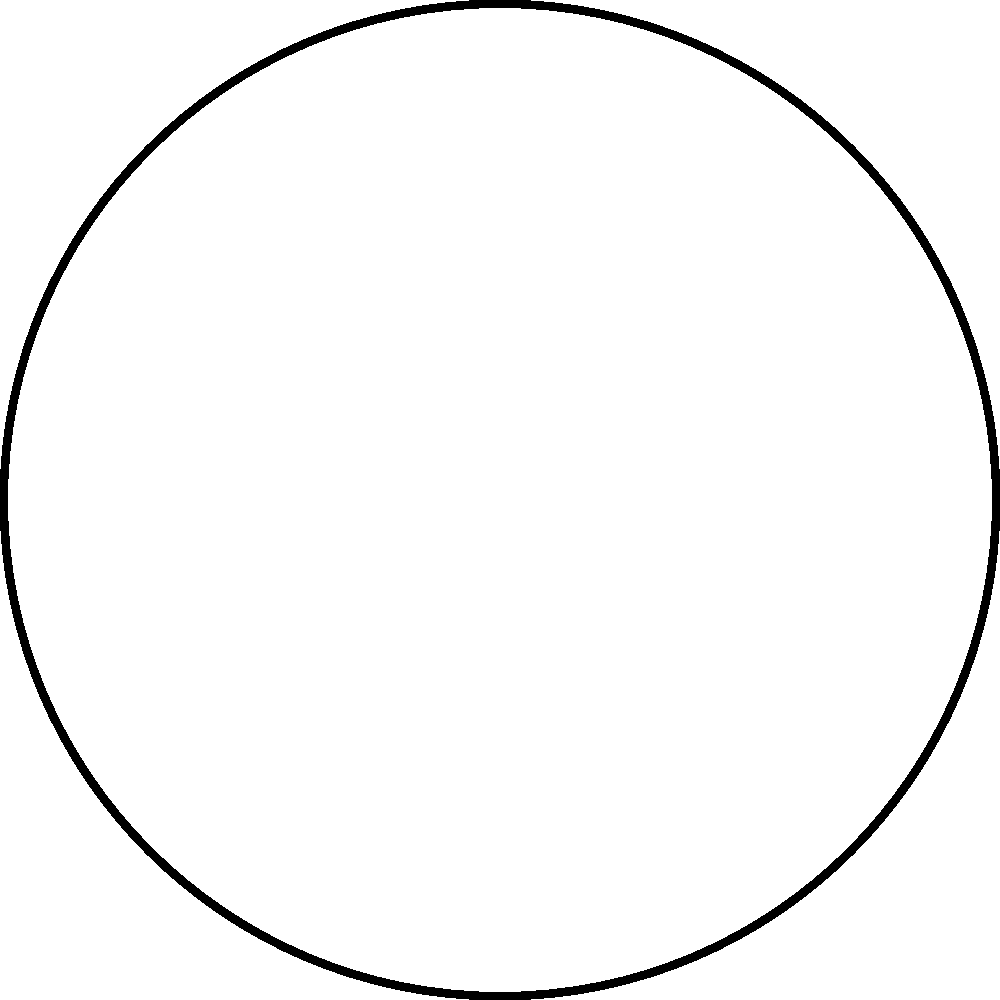A circular plate of radius $a$ and thickness $h$ is subjected to uniform pressure $p$. The plate is made of a material with Young's modulus $E$ and Poisson's ratio $\nu$. Using the small deflection theory, what is the maximum deflection $w_{max}$ at the center of the plate if it is simply supported at its edges? Express your answer in terms of the given parameters. To solve this problem, we'll use the small deflection theory for circular plates. The steps are as follows:

1) The governing equation for the deflection $w(r)$ of a circular plate under uniform pressure is:

   $$\frac{d}{dr}\left(r\frac{d}{dr}\left(\frac{1}{r}\frac{d}{dr}\left(r\frac{dw}{dr}\right)\right)\right) = \frac{p}{D}$$

   where $D$ is the flexural rigidity given by $D = \frac{Eh^3}{12(1-\nu^2)}$

2) For a simply supported plate, the boundary conditions are:
   - At $r=0$: $\frac{dw}{dr} = 0$ (symmetry condition)
   - At $r=a$: $w = 0$ and $M_r = 0$ (zero deflection and zero radial moment)

3) Solving the differential equation with these boundary conditions yields:

   $$w(r) = \frac{p}{64D}(a^2-r^2)(5+\nu)(a^2-r^2)$$

4) The maximum deflection occurs at the center of the plate $(r=0)$, so:

   $$w_{max} = w(0) = \frac{p}{64D}(a^2)^2(5+\nu)$$

5) Substituting the expression for $D$:

   $$w_{max} = \frac{pa^4}{64}\frac{12(1-\nu^2)}{Eh^3}(5+\nu)$$

6) Simplifying:

   $$w_{max} = \frac{3pa^4(1-\nu^2)(5+\nu)}{16Eh^3}$$

This is the final expression for the maximum deflection at the center of the simply supported circular plate under uniform pressure.
Answer: $w_{max} = \frac{3pa^4(1-\nu^2)(5+\nu)}{16Eh^3}$ 